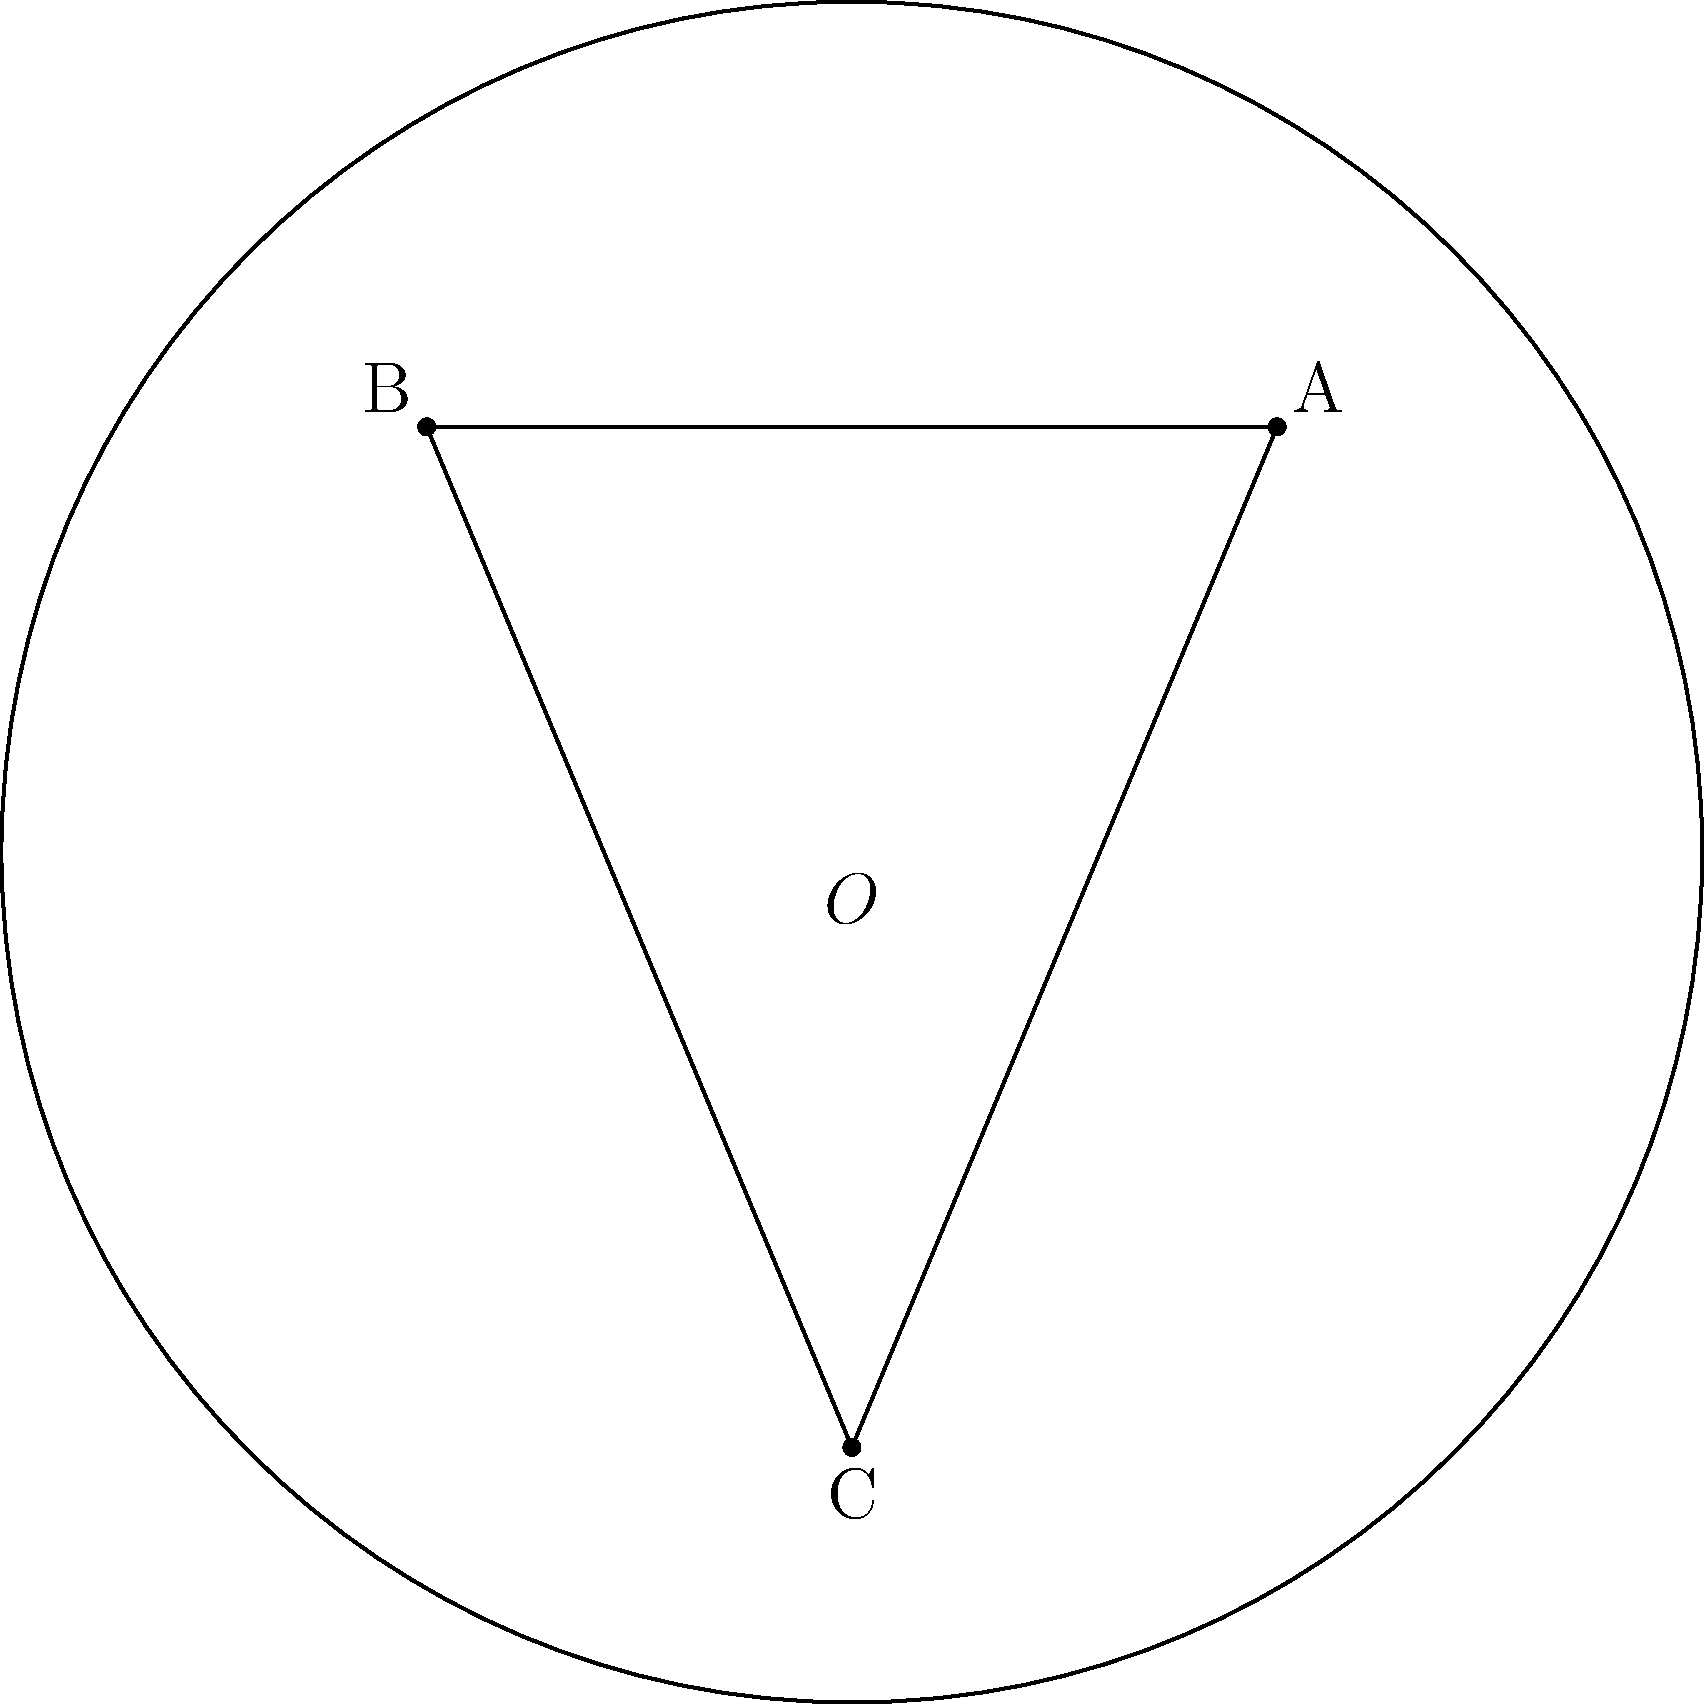In the Poincaré disk model of hyperbolic geometry shown above, triangle ABC is drawn. If the curvature of this hyperbolic plane is -1, what is the sum of the interior angles of triangle ABC? To solve this problem, we need to understand the properties of hyperbolic geometry and the Poincaré disk model:

1. In hyperbolic geometry, the sum of interior angles of a triangle is always less than 180°.

2. The Poincaré disk model represents the entire hyperbolic plane as the interior of a circle, where straight lines in hyperbolic space are represented by arcs of circles that are orthogonal to the boundary circle.

3. The curvature K of a hyperbolic plane is related to a constant R (the radius of curvature) by the equation: K = -1/R².

4. When K = -1, as given in the question, R = 1.

5. In hyperbolic geometry, the angle deficit (180° minus the sum of interior angles) is related to the area of the triangle and the curvature of the space.

6. The formula for the area A of a hyperbolic triangle with angles α, β, and γ (in radians) is:

   A = R²(π - α - β - γ)

7. Rearranging this formula, we get:

   α + β + γ = π - A/R²

8. Since K = -1 and R = 1, we have:

   α + β + γ = π - A

9. The area A of the triangle in the Poincaré disk model is always positive but less than π.

Therefore, the sum of the interior angles of triangle ABC is always positive but less than π radians (180°).
Answer: Between 0° and 180° 